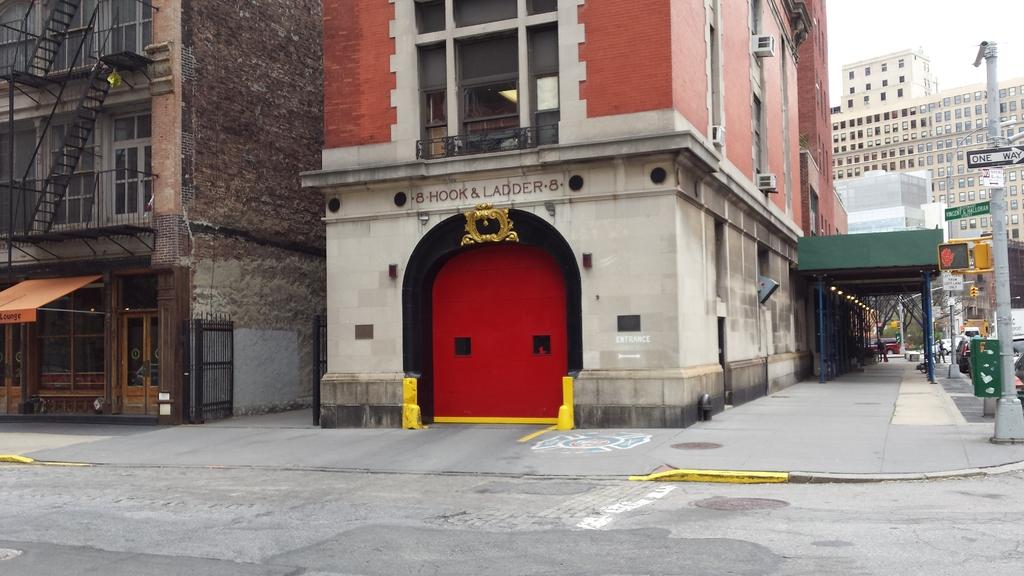What type of structures can be seen in the image? There are buildings in the image in the image. What architectural features are present in the buildings? There are windows and staircases in the image. What appliances can be seen in the image? There are air conditioners in the image. What type of signage is present in the image? There are sign boards in the image. What other objects can be seen in the image? There is a pole in the image. What mode of transportation is visible in the image? There are vehicles in the image. What part of the natural environment is visible in the image? The sky is visible in the image. Can you tell me how many yams are being used as decorations in the image? There are no yams present in the image; it features buildings, windows, staircases, air conditioners, sign boards, a pole, vehicles, and the sky. What type of bird can be seen perched on the pole in the image? There is no bird, specifically a robin, present in the image; it only features a pole and no living creatures. 